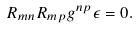Convert formula to latex. <formula><loc_0><loc_0><loc_500><loc_500>R _ { m n } R _ { m p } g ^ { n p } \epsilon = 0 .</formula> 